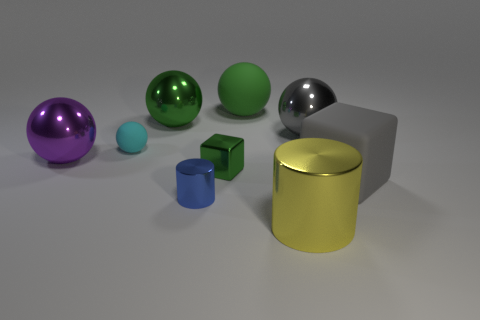What is the color of the tiny shiny thing behind the rubber thing that is in front of the green metallic object in front of the purple metal object?
Provide a succinct answer. Green. How many large balls are both in front of the small matte sphere and right of the cyan matte object?
Make the answer very short. 0. Is the color of the large matte thing behind the big green metal sphere the same as the cube left of the gray block?
Keep it short and to the point. Yes. The other matte object that is the same shape as the green rubber object is what size?
Provide a succinct answer. Small. Are there any large green objects behind the big green metal sphere?
Your answer should be very brief. Yes. Is the number of small cyan objects right of the small blue metallic cylinder the same as the number of tiny metal spheres?
Your answer should be compact. Yes. There is a big object that is behind the green ball that is on the left side of the small metallic cylinder; are there any gray metallic things behind it?
Make the answer very short. No. What is the big cube made of?
Keep it short and to the point. Rubber. What number of other things are the same shape as the cyan thing?
Offer a very short reply. 4. Is the big gray metal object the same shape as the tiny cyan thing?
Provide a succinct answer. Yes. 